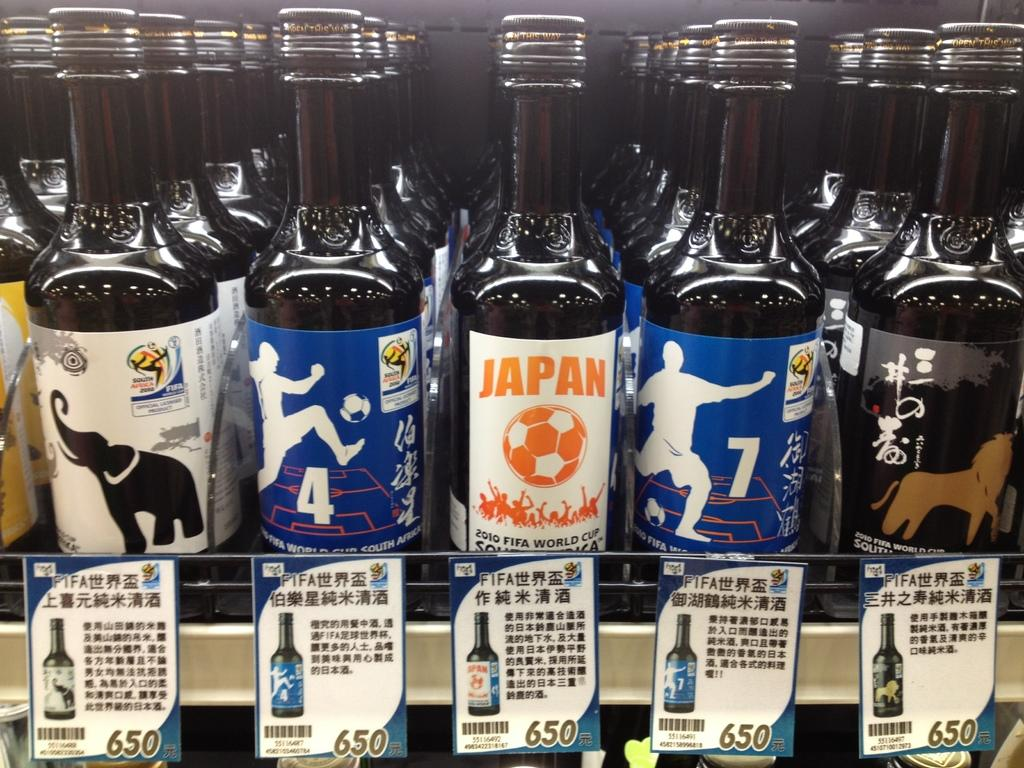<image>
Provide a brief description of the given image. many bottles of black liquid are lined up for sale, including a bottle labeled JAPAN 